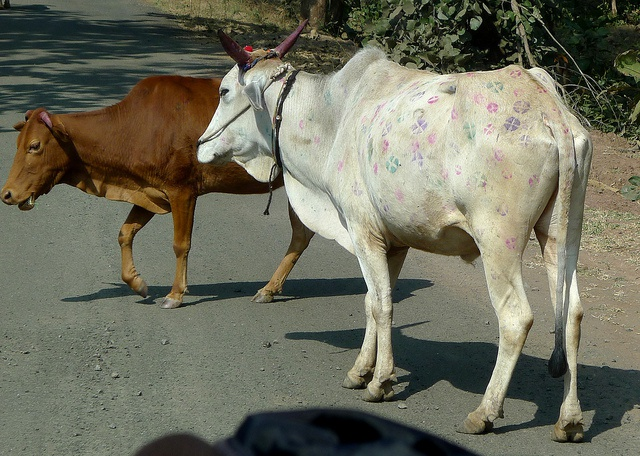Describe the objects in this image and their specific colors. I can see cow in black, darkgray, beige, and gray tones and cow in black, maroon, and olive tones in this image. 